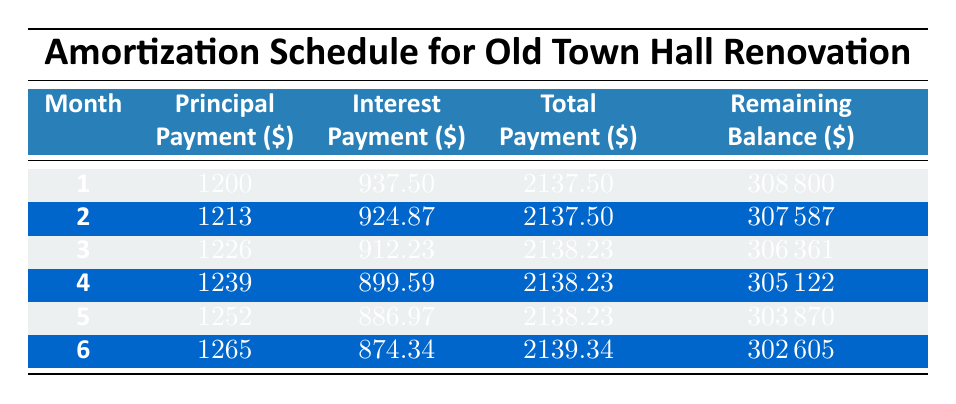What is the total payment made in the first month? The total payment for the first month is listed in the table under the "Total" column for "Month 1," which shows 2137.50.
Answer: 2137.50 How much was the remaining balance after the second month? For the second month, the remaining balance is provided in the "Remaining" column for "Month 2," which indicates 307587.
Answer: 307587 What was the total principal payment made after three months? To find the total principal payment after three months, add the principal payments for the first three months: 1200 + 1213 + 1226 = 3639.
Answer: 3639 Is the interest payment in the fourth month higher than in the third month? The interest payment for the fourth month is 899.59, and for the third month, it is 912.23. Since 899.59 is less than 912.23, the answer is no.
Answer: No What is the average total payment for the first six months? To find the average, first calculate the total of the total payments for the first six months: 2137.50 + 2137.50 + 2138.23 + 2138.23 + 2138.23 + 2139.34 = 12829.03. Then divide by 6 to get the average: 12829.03 / 6 = approximately 2138.17.
Answer: 2138.17 After the first month, how much principal is remaining to be paid? The initial loan amount is 310000, and after the first month, the remaining balance is 308800. Subtracting these gives: 310000 - 308800 = 1200.
Answer: 1200 What is the total interest payment made in the first six months? To find the total interest payment, sum the interest payments from months one to six: 937.50 + 924.87 + 912.23 + 899.59 + 886.97 + 874.34 = 4535.50.
Answer: 4535.50 Is the principal payment higher in the sixth month than in the first month? The principal payment for the sixth month is 1265, while for the first month it is 1200. Since 1265 is greater than 1200, the answer is yes.
Answer: Yes What is the change in remaining balance from the first month to the sixth month? The remaining balance after the first month is 308800, and after the sixth month it is 302605. The change is: 308800 - 302605 = 6195.
Answer: 6195 